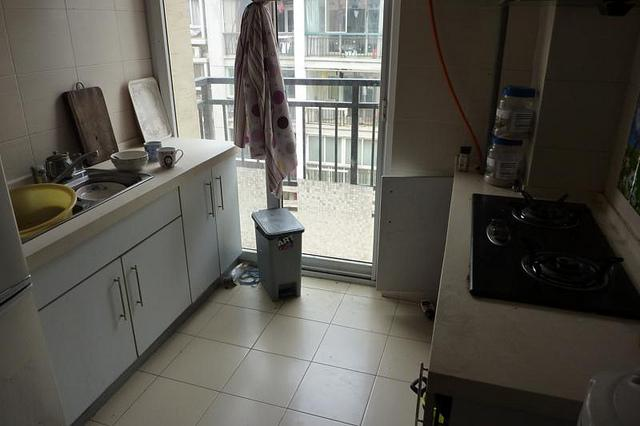In what type of housing complex is this kitchen part of? Please explain your reasoning. apartment. The complex is an apartment. 